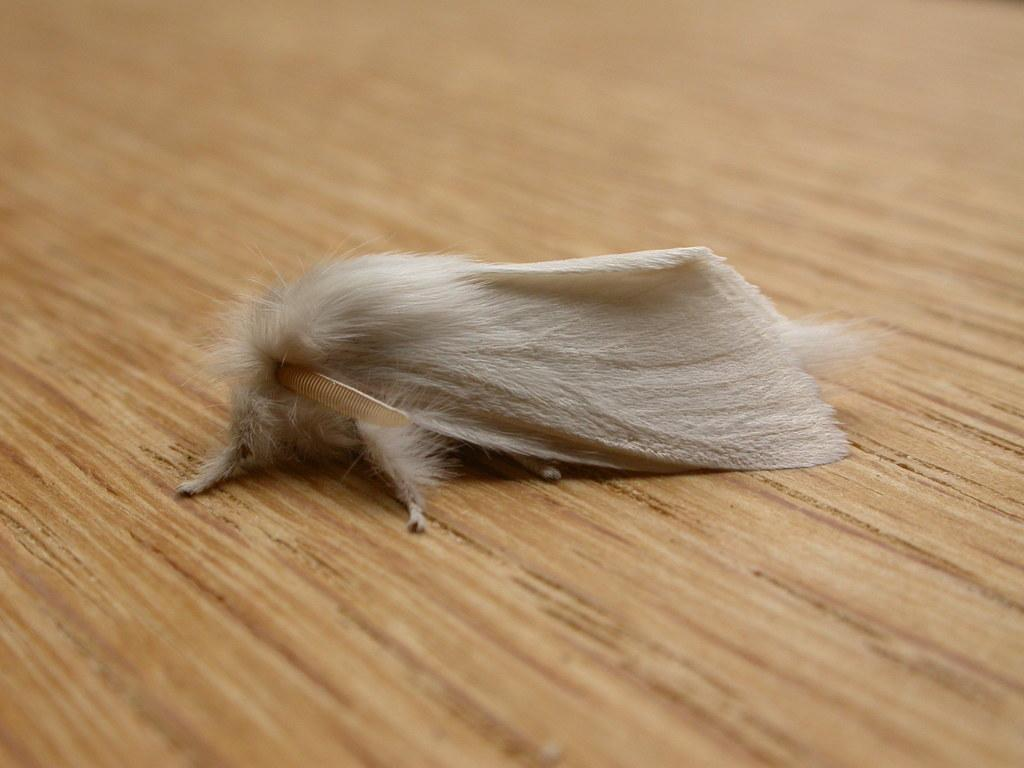What is the main subject in the center of the image? There is an animal in the center of the image. What type of surface is visible at the bottom of the image? There is a wooden floor at the bottom of the image. What is the animal in the image need a snake to survive? There is no snake present in the image, and the animal's survival does not depend on a snake. 